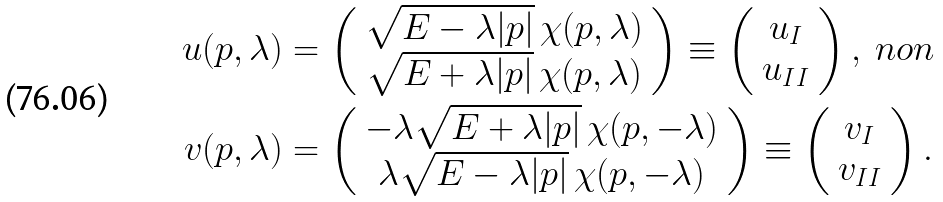Convert formula to latex. <formula><loc_0><loc_0><loc_500><loc_500>u ( p , \lambda ) & = \left ( \begin{array} { c } \sqrt { E - \lambda | { p } | } \, \chi ( { p } , \lambda ) \\ \sqrt { E + \lambda | { p } | } \, \chi ( { p } , \lambda ) \end{array} \right ) \equiv \left ( \begin{array} { c } u _ { I } \\ u _ { I I } \end{array} \right ) , \ n o n \\ v ( p , \lambda ) & = \left ( \begin{array} { c } - \lambda \sqrt { E + \lambda | { p } | } \, \chi ( { p } , - \lambda ) \\ \lambda \sqrt { E - \lambda | { p } | } \, \chi ( { p } , - \lambda ) \end{array} \right ) \equiv \left ( \begin{array} { c } v _ { I } \\ v _ { I I } \end{array} \right ) .</formula> 